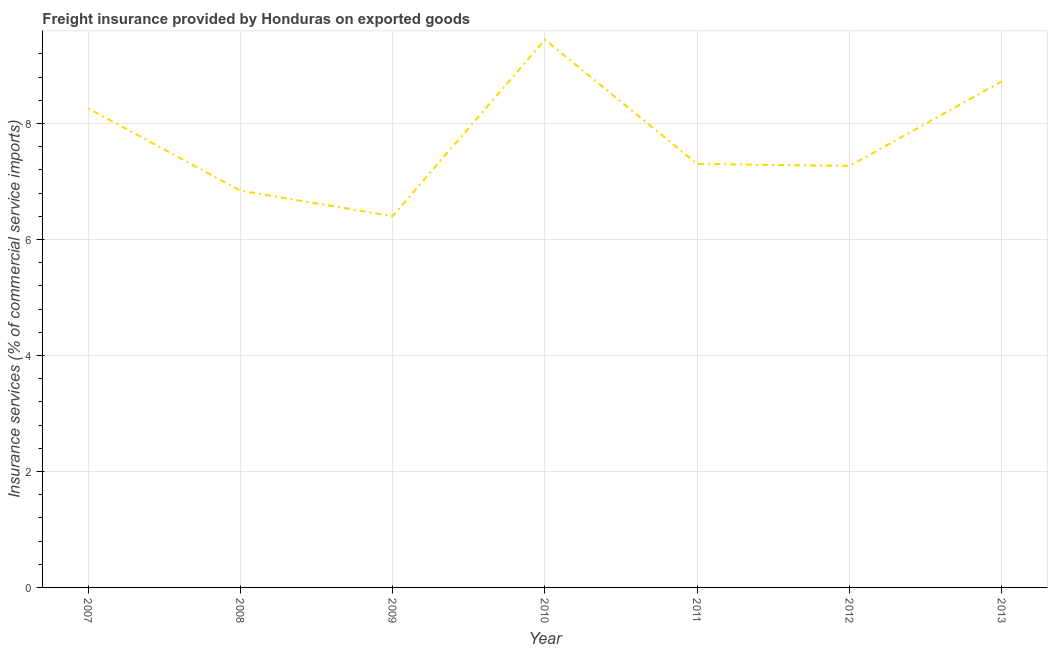What is the freight insurance in 2010?
Provide a succinct answer. 9.45. Across all years, what is the maximum freight insurance?
Offer a very short reply. 9.45. Across all years, what is the minimum freight insurance?
Make the answer very short. 6.4. In which year was the freight insurance maximum?
Your answer should be compact. 2010. In which year was the freight insurance minimum?
Make the answer very short. 2009. What is the sum of the freight insurance?
Give a very brief answer. 54.25. What is the difference between the freight insurance in 2008 and 2010?
Provide a succinct answer. -2.6. What is the average freight insurance per year?
Provide a short and direct response. 7.75. What is the median freight insurance?
Your response must be concise. 7.3. What is the ratio of the freight insurance in 2009 to that in 2012?
Make the answer very short. 0.88. What is the difference between the highest and the second highest freight insurance?
Your response must be concise. 0.72. Is the sum of the freight insurance in 2009 and 2013 greater than the maximum freight insurance across all years?
Your answer should be very brief. Yes. What is the difference between the highest and the lowest freight insurance?
Provide a short and direct response. 3.04. In how many years, is the freight insurance greater than the average freight insurance taken over all years?
Offer a very short reply. 3. How many lines are there?
Ensure brevity in your answer.  1. How many years are there in the graph?
Ensure brevity in your answer.  7. What is the difference between two consecutive major ticks on the Y-axis?
Make the answer very short. 2. Are the values on the major ticks of Y-axis written in scientific E-notation?
Your answer should be very brief. No. Does the graph contain any zero values?
Your answer should be very brief. No. What is the title of the graph?
Ensure brevity in your answer.  Freight insurance provided by Honduras on exported goods . What is the label or title of the X-axis?
Give a very brief answer. Year. What is the label or title of the Y-axis?
Make the answer very short. Insurance services (% of commercial service imports). What is the Insurance services (% of commercial service imports) in 2007?
Keep it short and to the point. 8.26. What is the Insurance services (% of commercial service imports) in 2008?
Offer a terse response. 6.84. What is the Insurance services (% of commercial service imports) in 2009?
Provide a short and direct response. 6.4. What is the Insurance services (% of commercial service imports) of 2010?
Keep it short and to the point. 9.45. What is the Insurance services (% of commercial service imports) of 2011?
Your answer should be compact. 7.3. What is the Insurance services (% of commercial service imports) of 2012?
Your response must be concise. 7.27. What is the Insurance services (% of commercial service imports) of 2013?
Offer a very short reply. 8.73. What is the difference between the Insurance services (% of commercial service imports) in 2007 and 2008?
Keep it short and to the point. 1.42. What is the difference between the Insurance services (% of commercial service imports) in 2007 and 2009?
Provide a short and direct response. 1.86. What is the difference between the Insurance services (% of commercial service imports) in 2007 and 2010?
Your answer should be very brief. -1.18. What is the difference between the Insurance services (% of commercial service imports) in 2007 and 2011?
Make the answer very short. 0.96. What is the difference between the Insurance services (% of commercial service imports) in 2007 and 2012?
Offer a terse response. 0.99. What is the difference between the Insurance services (% of commercial service imports) in 2007 and 2013?
Your answer should be very brief. -0.46. What is the difference between the Insurance services (% of commercial service imports) in 2008 and 2009?
Make the answer very short. 0.44. What is the difference between the Insurance services (% of commercial service imports) in 2008 and 2010?
Give a very brief answer. -2.6. What is the difference between the Insurance services (% of commercial service imports) in 2008 and 2011?
Keep it short and to the point. -0.46. What is the difference between the Insurance services (% of commercial service imports) in 2008 and 2012?
Keep it short and to the point. -0.43. What is the difference between the Insurance services (% of commercial service imports) in 2008 and 2013?
Offer a very short reply. -1.88. What is the difference between the Insurance services (% of commercial service imports) in 2009 and 2010?
Keep it short and to the point. -3.04. What is the difference between the Insurance services (% of commercial service imports) in 2009 and 2011?
Keep it short and to the point. -0.9. What is the difference between the Insurance services (% of commercial service imports) in 2009 and 2012?
Ensure brevity in your answer.  -0.87. What is the difference between the Insurance services (% of commercial service imports) in 2009 and 2013?
Give a very brief answer. -2.32. What is the difference between the Insurance services (% of commercial service imports) in 2010 and 2011?
Provide a succinct answer. 2.14. What is the difference between the Insurance services (% of commercial service imports) in 2010 and 2012?
Provide a short and direct response. 2.18. What is the difference between the Insurance services (% of commercial service imports) in 2010 and 2013?
Keep it short and to the point. 0.72. What is the difference between the Insurance services (% of commercial service imports) in 2011 and 2012?
Make the answer very short. 0.03. What is the difference between the Insurance services (% of commercial service imports) in 2011 and 2013?
Provide a short and direct response. -1.42. What is the difference between the Insurance services (% of commercial service imports) in 2012 and 2013?
Make the answer very short. -1.46. What is the ratio of the Insurance services (% of commercial service imports) in 2007 to that in 2008?
Your answer should be very brief. 1.21. What is the ratio of the Insurance services (% of commercial service imports) in 2007 to that in 2009?
Offer a very short reply. 1.29. What is the ratio of the Insurance services (% of commercial service imports) in 2007 to that in 2010?
Your answer should be very brief. 0.88. What is the ratio of the Insurance services (% of commercial service imports) in 2007 to that in 2011?
Provide a short and direct response. 1.13. What is the ratio of the Insurance services (% of commercial service imports) in 2007 to that in 2012?
Give a very brief answer. 1.14. What is the ratio of the Insurance services (% of commercial service imports) in 2007 to that in 2013?
Offer a terse response. 0.95. What is the ratio of the Insurance services (% of commercial service imports) in 2008 to that in 2009?
Ensure brevity in your answer.  1.07. What is the ratio of the Insurance services (% of commercial service imports) in 2008 to that in 2010?
Keep it short and to the point. 0.72. What is the ratio of the Insurance services (% of commercial service imports) in 2008 to that in 2011?
Offer a terse response. 0.94. What is the ratio of the Insurance services (% of commercial service imports) in 2008 to that in 2012?
Make the answer very short. 0.94. What is the ratio of the Insurance services (% of commercial service imports) in 2008 to that in 2013?
Offer a terse response. 0.78. What is the ratio of the Insurance services (% of commercial service imports) in 2009 to that in 2010?
Your answer should be very brief. 0.68. What is the ratio of the Insurance services (% of commercial service imports) in 2009 to that in 2011?
Ensure brevity in your answer.  0.88. What is the ratio of the Insurance services (% of commercial service imports) in 2009 to that in 2012?
Keep it short and to the point. 0.88. What is the ratio of the Insurance services (% of commercial service imports) in 2009 to that in 2013?
Your answer should be very brief. 0.73. What is the ratio of the Insurance services (% of commercial service imports) in 2010 to that in 2011?
Provide a succinct answer. 1.29. What is the ratio of the Insurance services (% of commercial service imports) in 2010 to that in 2012?
Your answer should be very brief. 1.3. What is the ratio of the Insurance services (% of commercial service imports) in 2010 to that in 2013?
Your response must be concise. 1.08. What is the ratio of the Insurance services (% of commercial service imports) in 2011 to that in 2013?
Make the answer very short. 0.84. What is the ratio of the Insurance services (% of commercial service imports) in 2012 to that in 2013?
Provide a succinct answer. 0.83. 